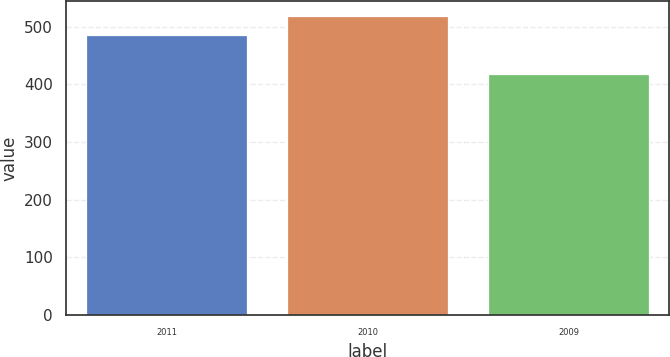<chart> <loc_0><loc_0><loc_500><loc_500><bar_chart><fcel>2011<fcel>2010<fcel>2009<nl><fcel>486.6<fcel>519<fcel>417.6<nl></chart> 